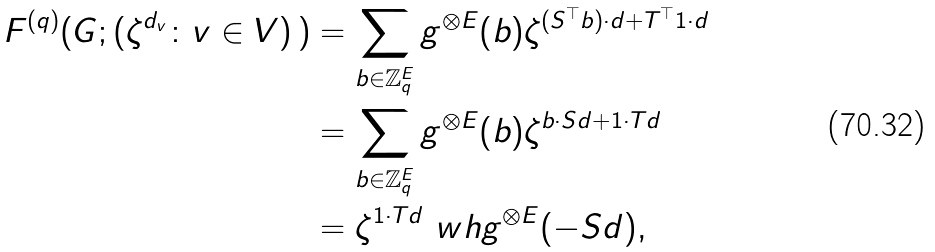Convert formula to latex. <formula><loc_0><loc_0><loc_500><loc_500>F ^ { ( q ) } ( G ; ( \zeta ^ { d _ { v } } \colon v \in V ) \, ) & = \sum _ { b \in \mathbb { Z } _ { q } ^ { E } } g ^ { \otimes E } ( b ) \zeta ^ { ( S ^ { \top } b ) \cdot d + T ^ { \top } 1 \cdot d } \\ & = \sum _ { b \in \mathbb { Z } _ { q } ^ { E } } g ^ { \otimes E } ( b ) \zeta ^ { b \cdot S d + 1 \cdot T d } \\ & = \zeta ^ { 1 \cdot T d } \ w h { g } ^ { \otimes E } ( - S d ) ,</formula> 